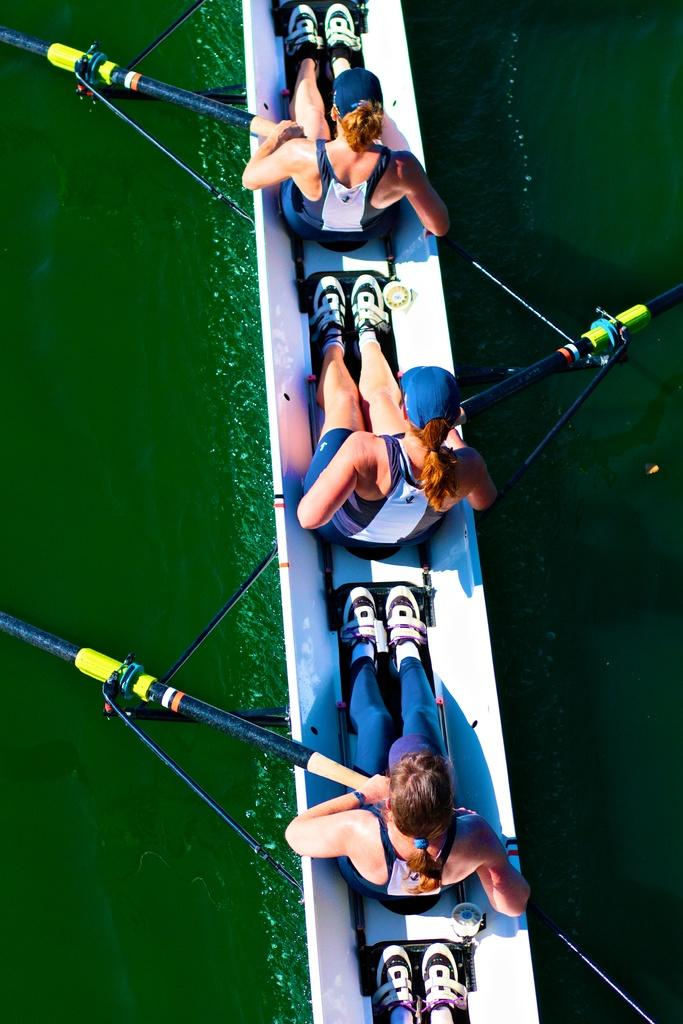How many people are in the image? There are three persons in the image. What are the persons doing in the image? The persons are boating in the water. What are the persons holding in their hands? The persons are holding objects in their hands. Can you describe the time of day when the image might have been taken? The image might have been taken during the day. How many elbows can be seen in the image? There is no specific mention of elbows in the image, so it is impossible to determine the number of elbows visible. 